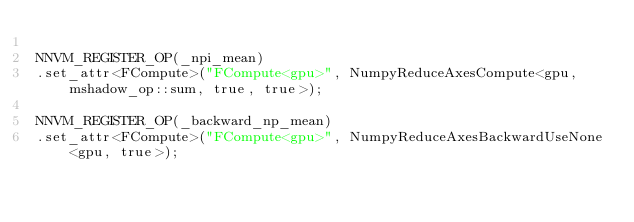<code> <loc_0><loc_0><loc_500><loc_500><_Cuda_>
NNVM_REGISTER_OP(_npi_mean)
.set_attr<FCompute>("FCompute<gpu>", NumpyReduceAxesCompute<gpu, mshadow_op::sum, true, true>);

NNVM_REGISTER_OP(_backward_np_mean)
.set_attr<FCompute>("FCompute<gpu>", NumpyReduceAxesBackwardUseNone<gpu, true>);
</code> 